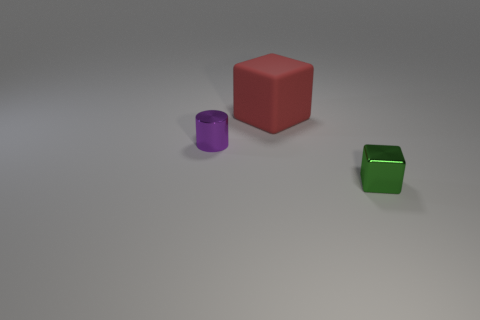Add 2 tiny green cubes. How many objects exist? 5 Subtract all blocks. How many objects are left? 1 Subtract all small gray things. Subtract all big red blocks. How many objects are left? 2 Add 1 matte cubes. How many matte cubes are left? 2 Add 3 small green objects. How many small green objects exist? 4 Subtract 0 red cylinders. How many objects are left? 3 